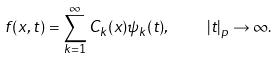<formula> <loc_0><loc_0><loc_500><loc_500>f ( x , t ) = \sum _ { k = 1 } ^ { \infty } C _ { k } ( x ) \psi _ { k } ( t ) , \quad | t | _ { p } \to \infty .</formula> 